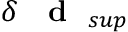Convert formula to latex. <formula><loc_0><loc_0><loc_500><loc_500>\delta { d } _ { s u p }</formula> 